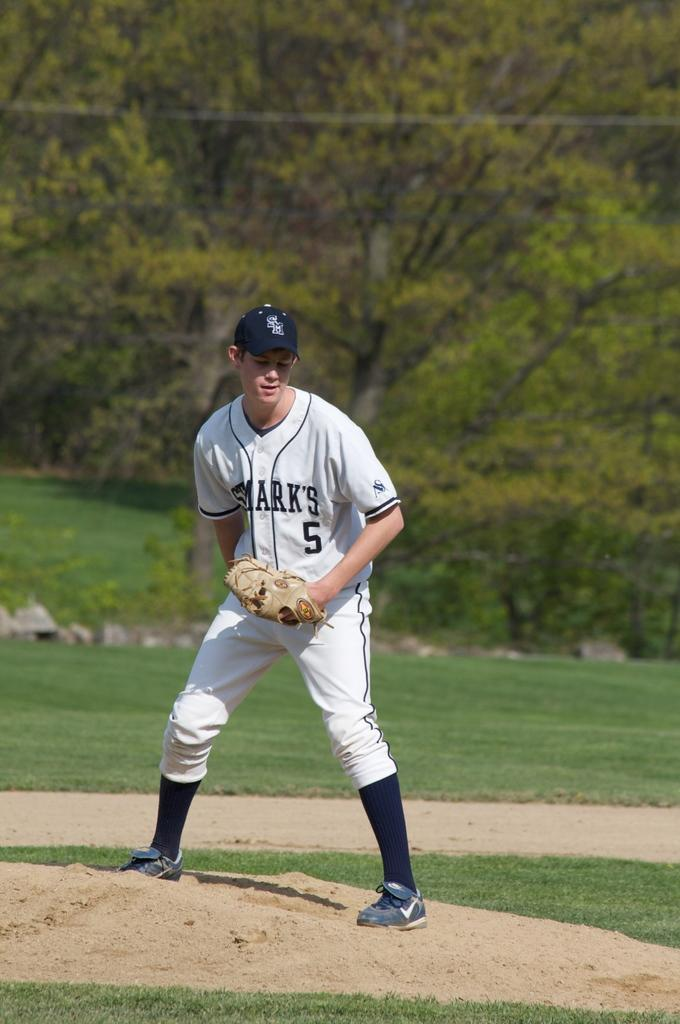Provide a one-sentence caption for the provided image. pitcher for st marks number 5 on the pitchers mound. 